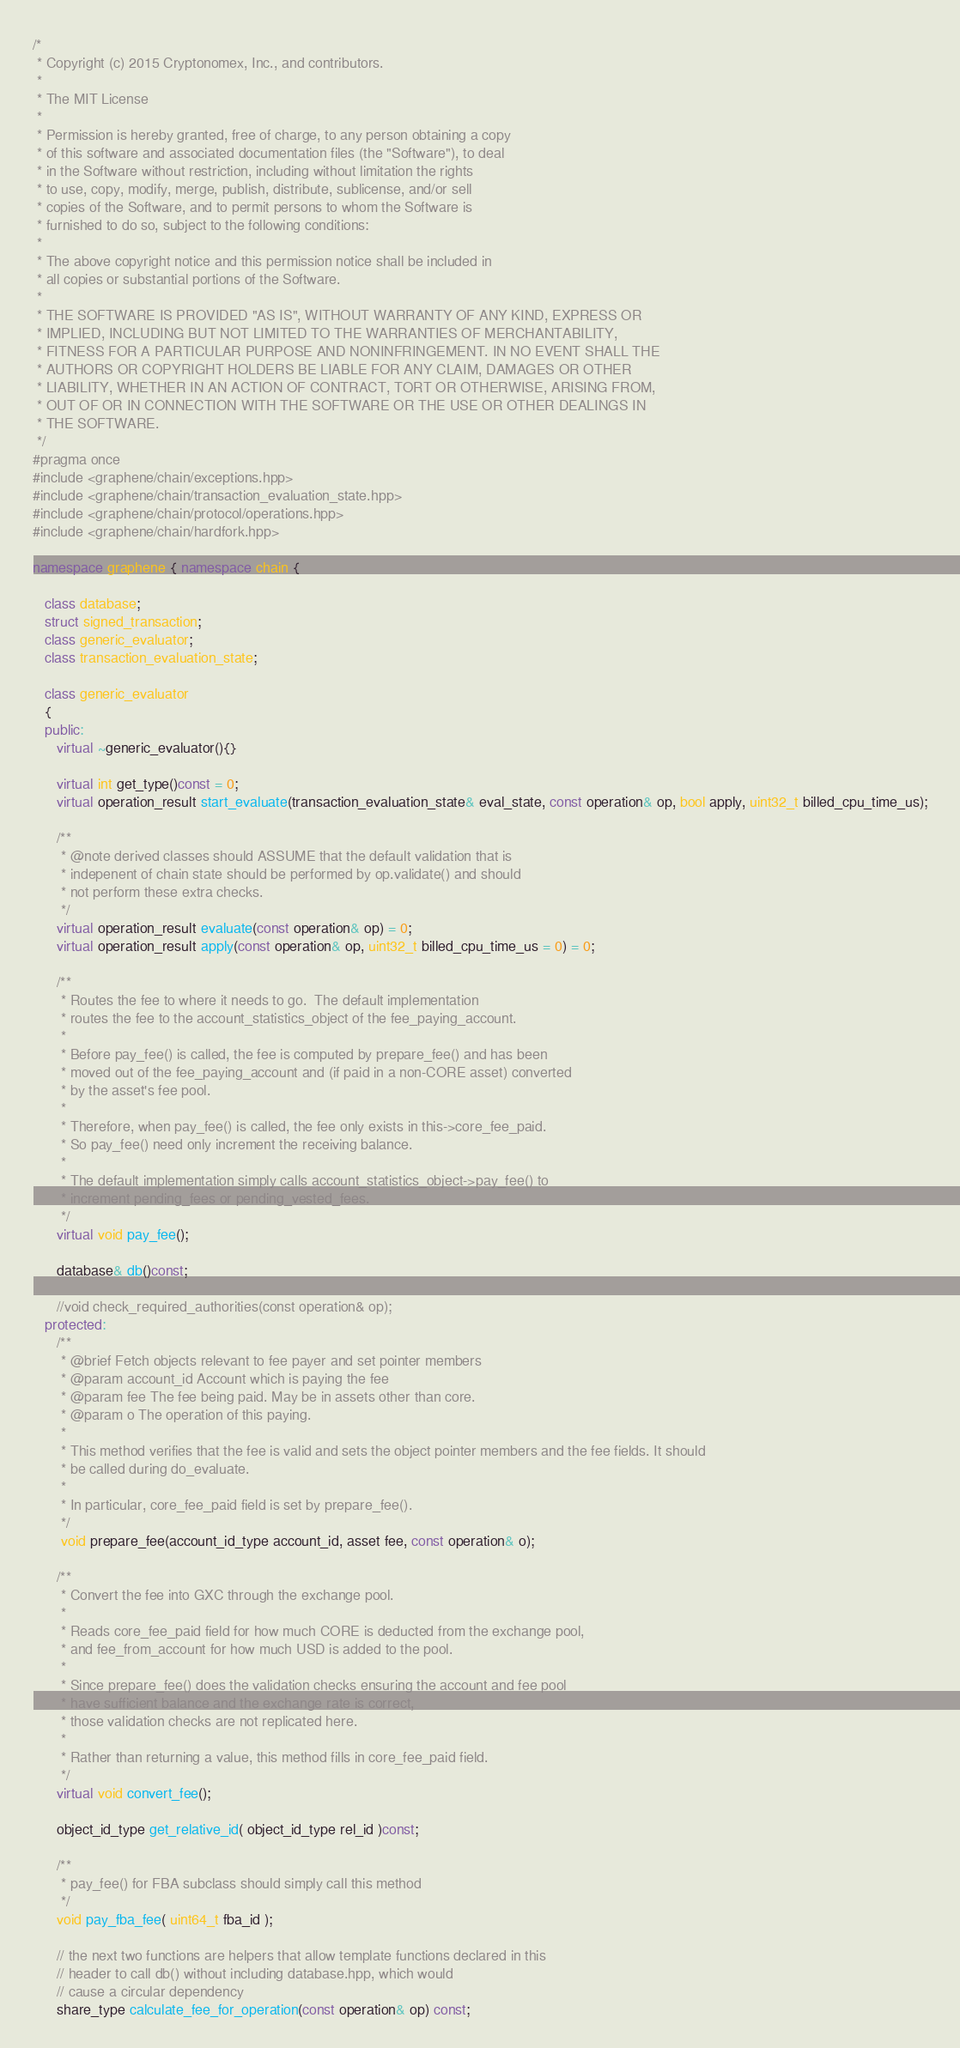Convert code to text. <code><loc_0><loc_0><loc_500><loc_500><_C++_>/*
 * Copyright (c) 2015 Cryptonomex, Inc., and contributors.
 *
 * The MIT License
 *
 * Permission is hereby granted, free of charge, to any person obtaining a copy
 * of this software and associated documentation files (the "Software"), to deal
 * in the Software without restriction, including without limitation the rights
 * to use, copy, modify, merge, publish, distribute, sublicense, and/or sell
 * copies of the Software, and to permit persons to whom the Software is
 * furnished to do so, subject to the following conditions:
 *
 * The above copyright notice and this permission notice shall be included in
 * all copies or substantial portions of the Software.
 *
 * THE SOFTWARE IS PROVIDED "AS IS", WITHOUT WARRANTY OF ANY KIND, EXPRESS OR
 * IMPLIED, INCLUDING BUT NOT LIMITED TO THE WARRANTIES OF MERCHANTABILITY,
 * FITNESS FOR A PARTICULAR PURPOSE AND NONINFRINGEMENT. IN NO EVENT SHALL THE
 * AUTHORS OR COPYRIGHT HOLDERS BE LIABLE FOR ANY CLAIM, DAMAGES OR OTHER
 * LIABILITY, WHETHER IN AN ACTION OF CONTRACT, TORT OR OTHERWISE, ARISING FROM,
 * OUT OF OR IN CONNECTION WITH THE SOFTWARE OR THE USE OR OTHER DEALINGS IN
 * THE SOFTWARE.
 */
#pragma once
#include <graphene/chain/exceptions.hpp>
#include <graphene/chain/transaction_evaluation_state.hpp>
#include <graphene/chain/protocol/operations.hpp>
#include <graphene/chain/hardfork.hpp>

namespace graphene { namespace chain {

   class database;
   struct signed_transaction;
   class generic_evaluator;
   class transaction_evaluation_state;

   class generic_evaluator
   {
   public:
      virtual ~generic_evaluator(){}

      virtual int get_type()const = 0;
      virtual operation_result start_evaluate(transaction_evaluation_state& eval_state, const operation& op, bool apply, uint32_t billed_cpu_time_us);

      /**
       * @note derived classes should ASSUME that the default validation that is
       * indepenent of chain state should be performed by op.validate() and should
       * not perform these extra checks.
       */
      virtual operation_result evaluate(const operation& op) = 0;
      virtual operation_result apply(const operation& op, uint32_t billed_cpu_time_us = 0) = 0;

      /**
       * Routes the fee to where it needs to go.  The default implementation
       * routes the fee to the account_statistics_object of the fee_paying_account.
       *
       * Before pay_fee() is called, the fee is computed by prepare_fee() and has been
       * moved out of the fee_paying_account and (if paid in a non-CORE asset) converted
       * by the asset's fee pool.
       *
       * Therefore, when pay_fee() is called, the fee only exists in this->core_fee_paid.
       * So pay_fee() need only increment the receiving balance.
       *
       * The default implementation simply calls account_statistics_object->pay_fee() to
       * increment pending_fees or pending_vested_fees.
       */
      virtual void pay_fee();

      database& db()const;

      //void check_required_authorities(const operation& op);
   protected:
      /**
       * @brief Fetch objects relevant to fee payer and set pointer members
       * @param account_id Account which is paying the fee
       * @param fee The fee being paid. May be in assets other than core.
       * @param o The operation of this paying.
       *
       * This method verifies that the fee is valid and sets the object pointer members and the fee fields. It should
       * be called during do_evaluate.
       *
       * In particular, core_fee_paid field is set by prepare_fee().
       */
       void prepare_fee(account_id_type account_id, asset fee, const operation& o);

      /**
       * Convert the fee into GXC through the exchange pool.
       *
       * Reads core_fee_paid field for how much CORE is deducted from the exchange pool,
       * and fee_from_account for how much USD is added to the pool.
       *
       * Since prepare_fee() does the validation checks ensuring the account and fee pool
       * have sufficient balance and the exchange rate is correct,
       * those validation checks are not replicated here.
       *
       * Rather than returning a value, this method fills in core_fee_paid field.
       */
      virtual void convert_fee();

      object_id_type get_relative_id( object_id_type rel_id )const;

      /**
       * pay_fee() for FBA subclass should simply call this method
       */
      void pay_fba_fee( uint64_t fba_id );

      // the next two functions are helpers that allow template functions declared in this 
      // header to call db() without including database.hpp, which would
      // cause a circular dependency
      share_type calculate_fee_for_operation(const operation& op) const;</code> 